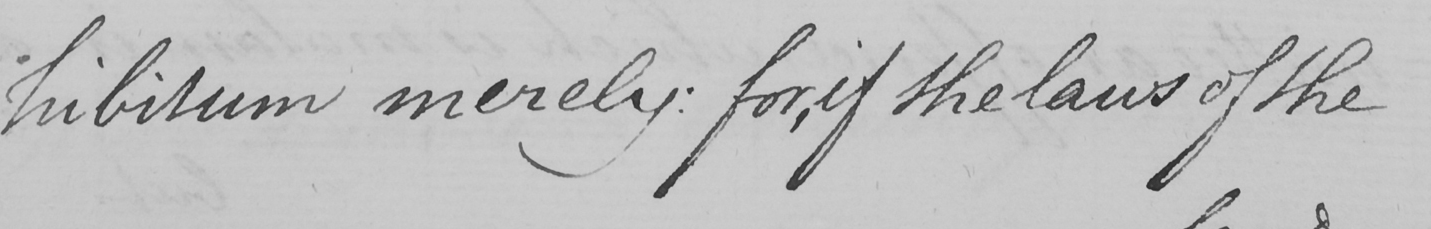What text is written in this handwritten line? hibitum merely :  for , if the laws of the 